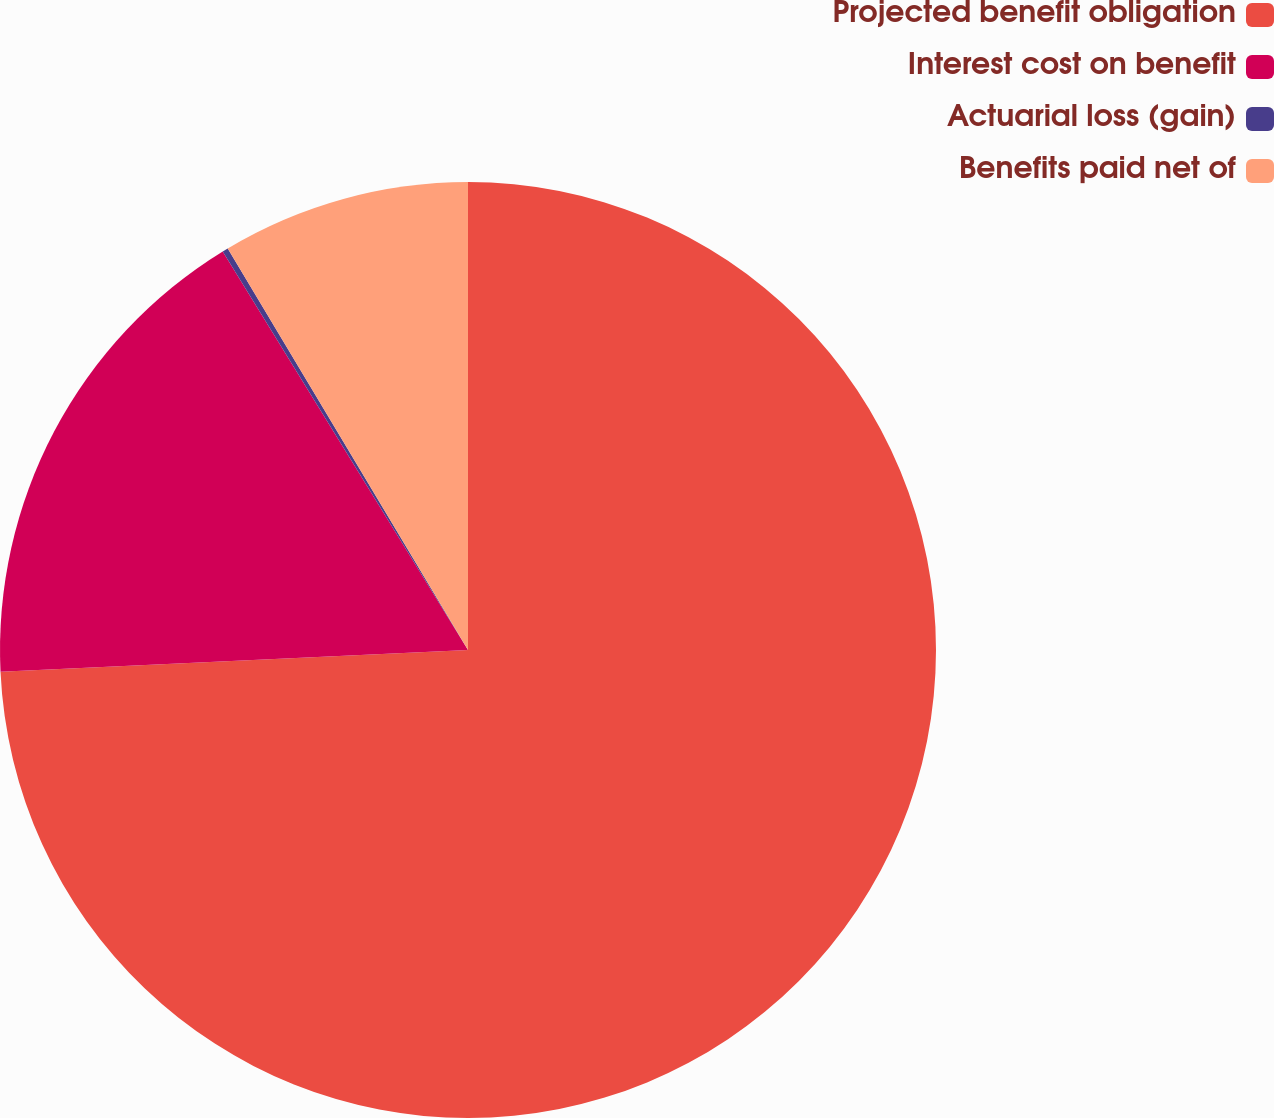Convert chart. <chart><loc_0><loc_0><loc_500><loc_500><pie_chart><fcel>Projected benefit obligation<fcel>Interest cost on benefit<fcel>Actuarial loss (gain)<fcel>Benefits paid net of<nl><fcel>74.26%<fcel>16.96%<fcel>0.2%<fcel>8.58%<nl></chart> 